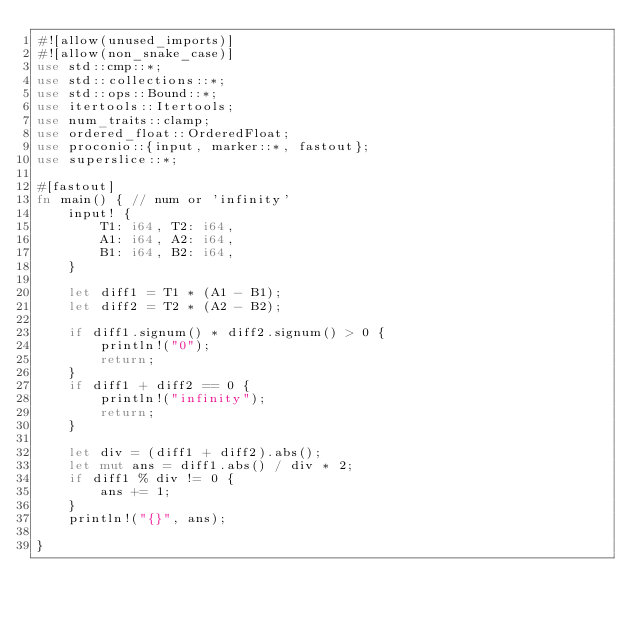<code> <loc_0><loc_0><loc_500><loc_500><_Rust_>#![allow(unused_imports)]
#![allow(non_snake_case)]
use std::cmp::*;
use std::collections::*;
use std::ops::Bound::*;
use itertools::Itertools;
use num_traits::clamp;
use ordered_float::OrderedFloat;
use proconio::{input, marker::*, fastout};
use superslice::*;

#[fastout]
fn main() { // num or 'infinity'
    input! {
        T1: i64, T2: i64,
        A1: i64, A2: i64, 
        B1: i64, B2: i64,
    }

    let diff1 = T1 * (A1 - B1);
    let diff2 = T2 * (A2 - B2);

    if diff1.signum() * diff2.signum() > 0 {
        println!("0");
        return;
    }
    if diff1 + diff2 == 0 {
        println!("infinity");
        return;
    }

    let div = (diff1 + diff2).abs();
    let mut ans = diff1.abs() / div * 2;
    if diff1 % div != 0 {
        ans += 1;
    }
    println!("{}", ans);

}
</code> 